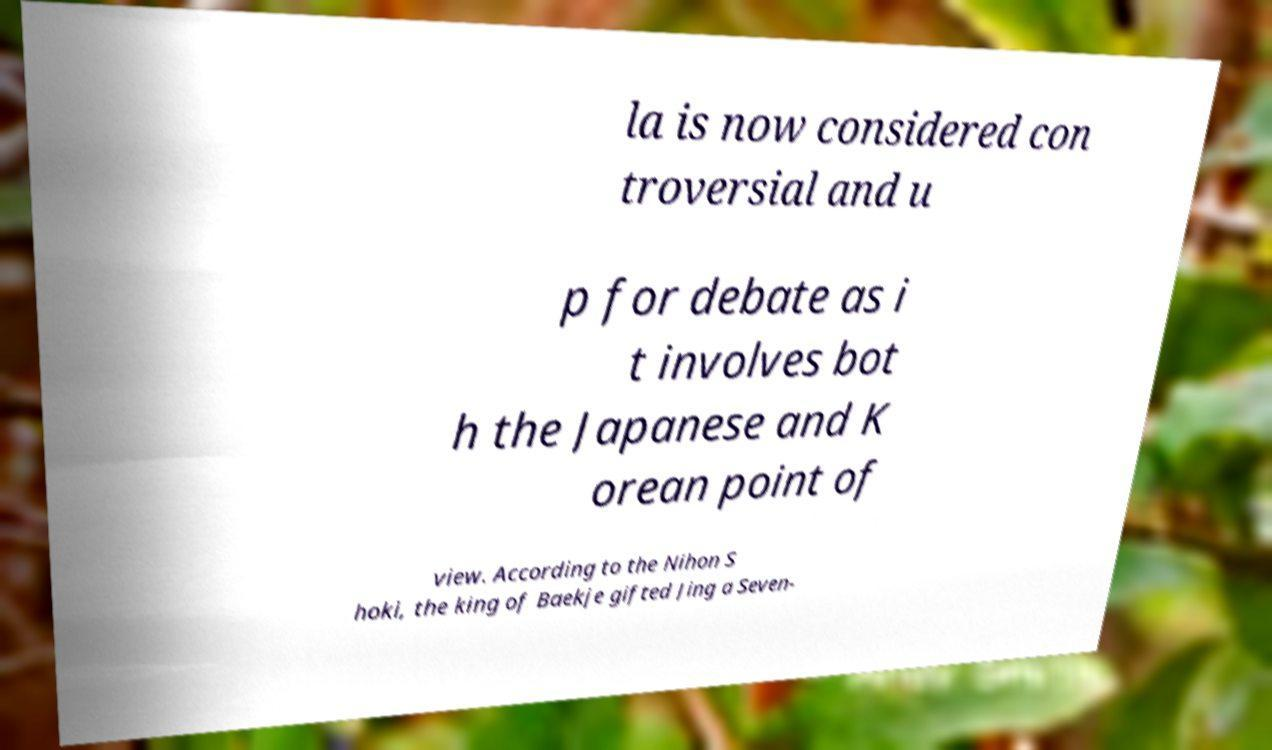I need the written content from this picture converted into text. Can you do that? la is now considered con troversial and u p for debate as i t involves bot h the Japanese and K orean point of view. According to the Nihon S hoki, the king of Baekje gifted Jing a Seven- 